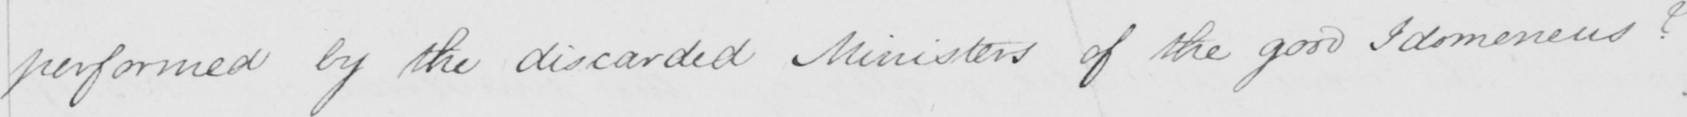Transcribe the text shown in this historical manuscript line. performed by the discarded Ministers of the good Idomeneus ? 